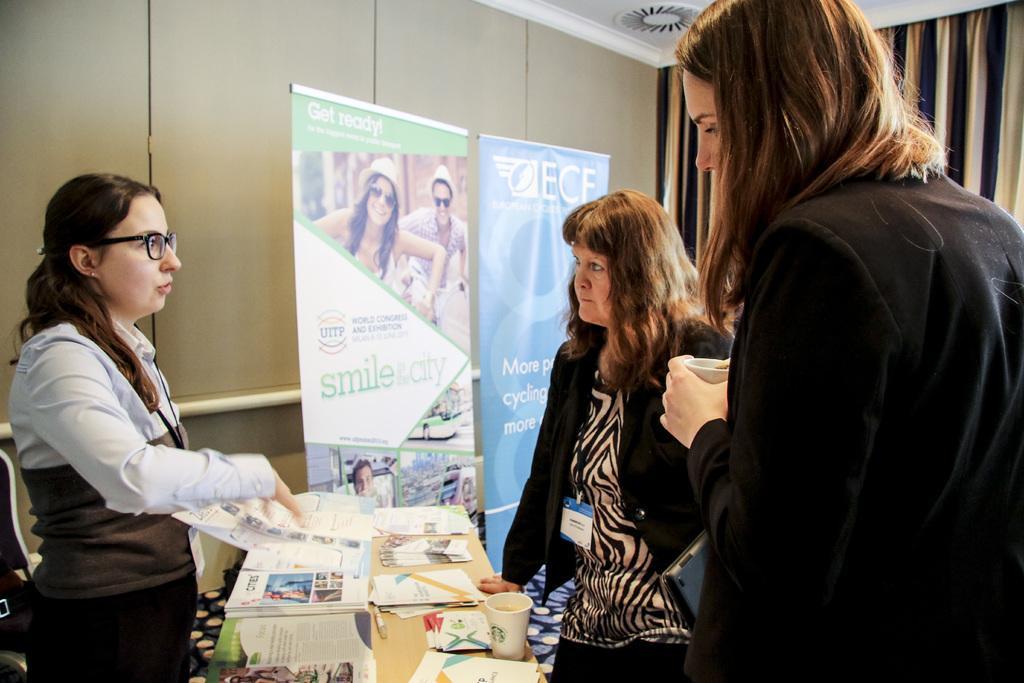How would you summarize this image in a sentence or two? There are three women standing. This is a table. I can see books, papers, cup and few other things on it. These are the banners. This looks like a wall. On the right side of the image, I think these are the curtains hanging. 